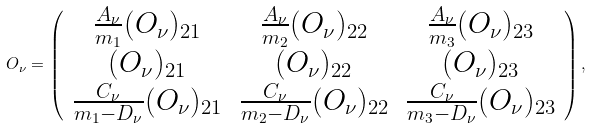<formula> <loc_0><loc_0><loc_500><loc_500>O _ { \nu } = \left ( \begin{array} { c c c } \frac { A _ { \nu } } { m _ { 1 } } ( O _ { \nu } ) _ { 2 1 } & \frac { A _ { \nu } } { m _ { 2 } } ( O _ { \nu } ) _ { 2 2 } & \frac { A _ { \nu } } { m _ { 3 } } ( O _ { \nu } ) _ { 2 3 } \\ ( O _ { \nu } ) _ { 2 1 } & ( O _ { \nu } ) _ { 2 2 } & ( O _ { \nu } ) _ { 2 3 } \\ \frac { C _ { \nu } } { m _ { 1 } - D _ { \nu } } ( O _ { \nu } ) _ { 2 1 } & \frac { C _ { \nu } } { m _ { 2 } - D _ { \nu } } ( O _ { \nu } ) _ { 2 2 } & \frac { C _ { \nu } } { m _ { 3 } - D _ { \nu } } ( O _ { \nu } ) _ { 2 3 } \end{array} \right ) ,</formula> 